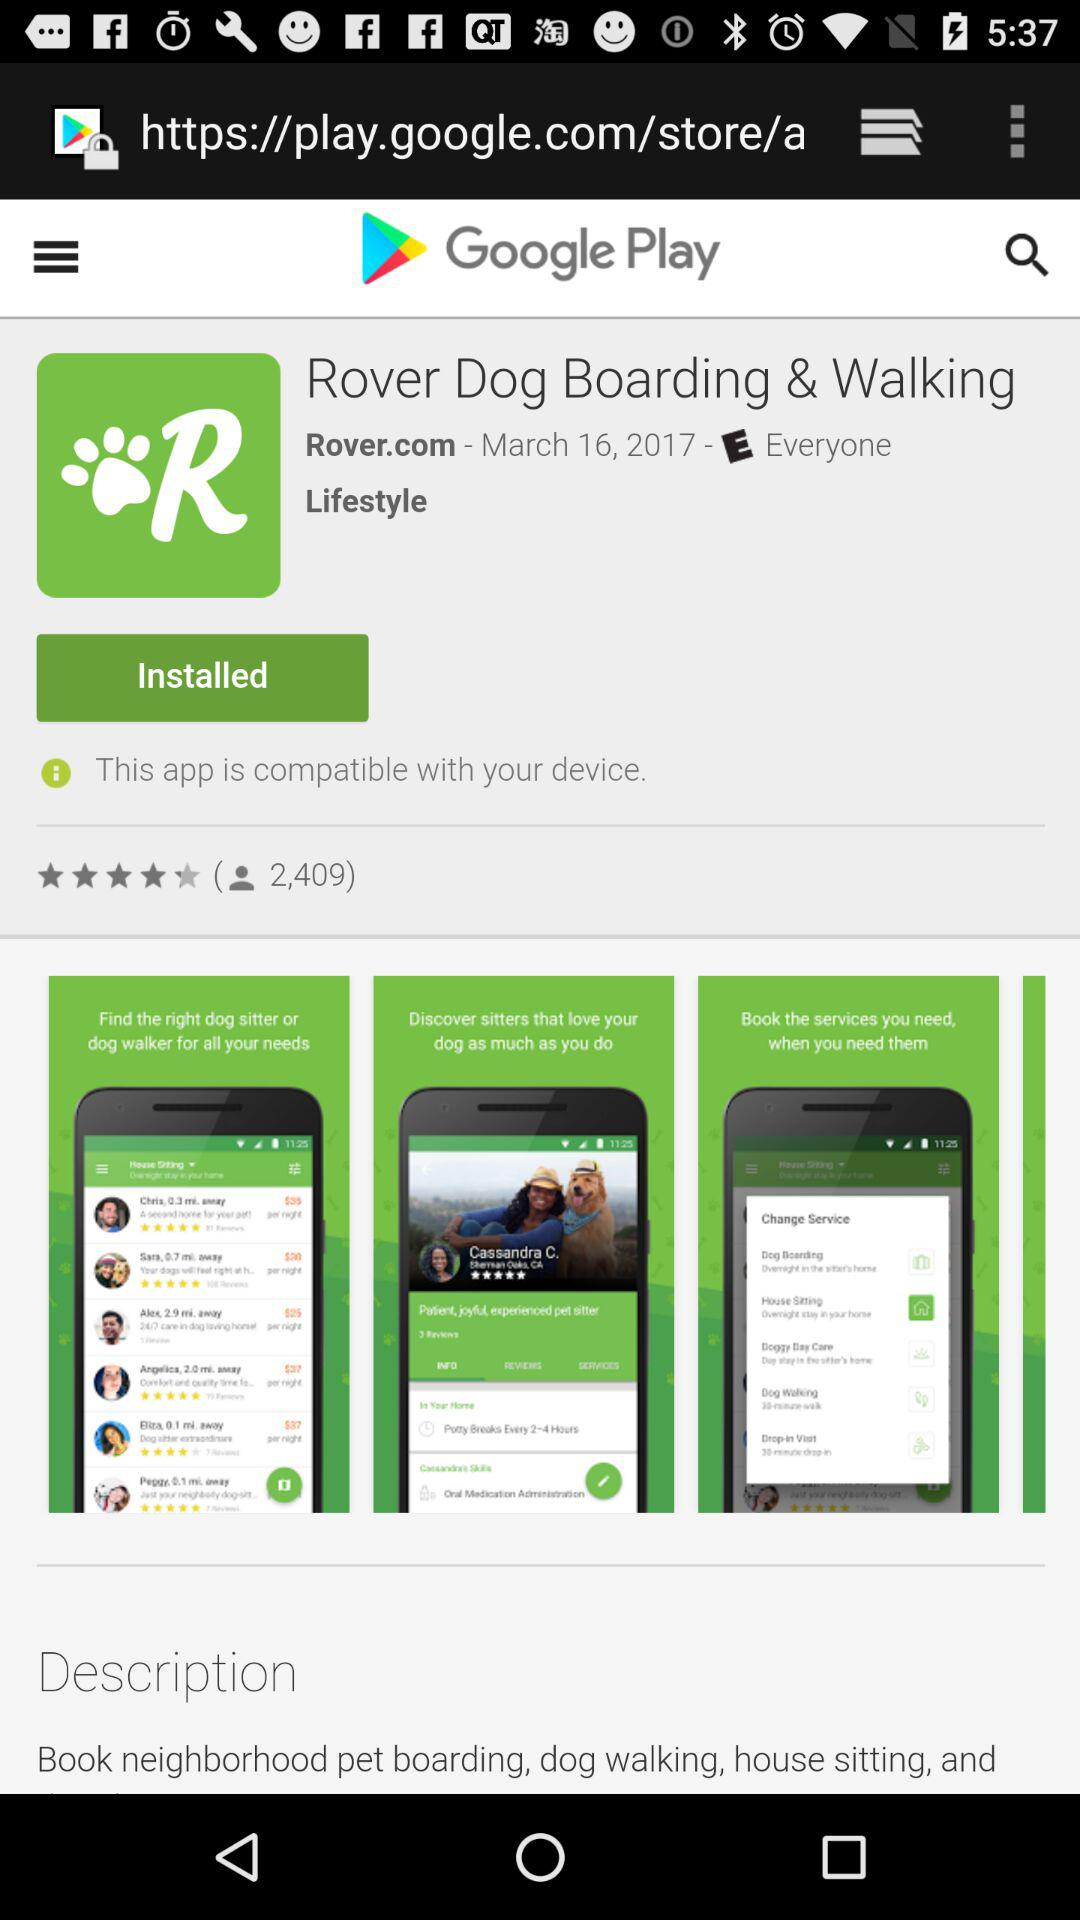How much is the app?
When the provided information is insufficient, respond with <no answer>. <no answer> 